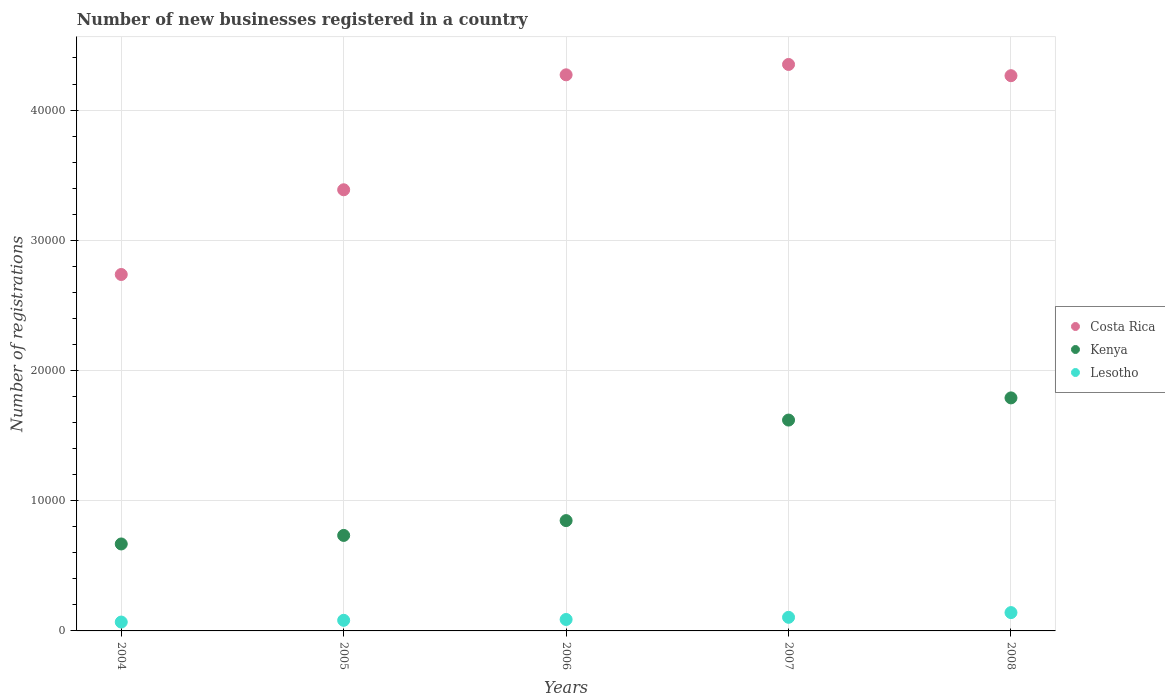Is the number of dotlines equal to the number of legend labels?
Make the answer very short. Yes. What is the number of new businesses registered in Kenya in 2005?
Provide a short and direct response. 7334. Across all years, what is the maximum number of new businesses registered in Costa Rica?
Ensure brevity in your answer.  4.35e+04. Across all years, what is the minimum number of new businesses registered in Lesotho?
Give a very brief answer. 681. In which year was the number of new businesses registered in Lesotho maximum?
Make the answer very short. 2008. In which year was the number of new businesses registered in Lesotho minimum?
Your answer should be compact. 2004. What is the total number of new businesses registered in Lesotho in the graph?
Keep it short and to the point. 4826. What is the difference between the number of new businesses registered in Lesotho in 2005 and that in 2006?
Your answer should be very brief. -65. What is the difference between the number of new businesses registered in Lesotho in 2005 and the number of new businesses registered in Costa Rica in 2007?
Offer a terse response. -4.27e+04. What is the average number of new businesses registered in Costa Rica per year?
Your response must be concise. 3.80e+04. In the year 2008, what is the difference between the number of new businesses registered in Lesotho and number of new businesses registered in Kenya?
Your answer should be very brief. -1.65e+04. What is the ratio of the number of new businesses registered in Costa Rica in 2004 to that in 2006?
Ensure brevity in your answer.  0.64. Is the number of new businesses registered in Costa Rica in 2005 less than that in 2008?
Provide a succinct answer. Yes. Is the difference between the number of new businesses registered in Lesotho in 2005 and 2007 greater than the difference between the number of new businesses registered in Kenya in 2005 and 2007?
Make the answer very short. Yes. What is the difference between the highest and the second highest number of new businesses registered in Kenya?
Your answer should be very brief. 1703. What is the difference between the highest and the lowest number of new businesses registered in Lesotho?
Provide a short and direct response. 726. Does the number of new businesses registered in Costa Rica monotonically increase over the years?
Your answer should be very brief. No. How many years are there in the graph?
Your answer should be very brief. 5. Does the graph contain any zero values?
Your answer should be compact. No. How many legend labels are there?
Provide a succinct answer. 3. What is the title of the graph?
Keep it short and to the point. Number of new businesses registered in a country. Does "Ecuador" appear as one of the legend labels in the graph?
Provide a short and direct response. No. What is the label or title of the X-axis?
Give a very brief answer. Years. What is the label or title of the Y-axis?
Give a very brief answer. Number of registrations. What is the Number of registrations in Costa Rica in 2004?
Offer a terse response. 2.74e+04. What is the Number of registrations in Kenya in 2004?
Offer a terse response. 6678. What is the Number of registrations of Lesotho in 2004?
Provide a succinct answer. 681. What is the Number of registrations of Costa Rica in 2005?
Give a very brief answer. 3.39e+04. What is the Number of registrations in Kenya in 2005?
Keep it short and to the point. 7334. What is the Number of registrations in Lesotho in 2005?
Your answer should be compact. 814. What is the Number of registrations of Costa Rica in 2006?
Provide a short and direct response. 4.27e+04. What is the Number of registrations of Kenya in 2006?
Offer a very short reply. 8472. What is the Number of registrations of Lesotho in 2006?
Provide a succinct answer. 879. What is the Number of registrations in Costa Rica in 2007?
Ensure brevity in your answer.  4.35e+04. What is the Number of registrations in Kenya in 2007?
Your answer should be very brief. 1.62e+04. What is the Number of registrations of Lesotho in 2007?
Make the answer very short. 1045. What is the Number of registrations of Costa Rica in 2008?
Keep it short and to the point. 4.26e+04. What is the Number of registrations of Kenya in 2008?
Your response must be concise. 1.79e+04. What is the Number of registrations of Lesotho in 2008?
Make the answer very short. 1407. Across all years, what is the maximum Number of registrations in Costa Rica?
Provide a short and direct response. 4.35e+04. Across all years, what is the maximum Number of registrations in Kenya?
Keep it short and to the point. 1.79e+04. Across all years, what is the maximum Number of registrations in Lesotho?
Make the answer very short. 1407. Across all years, what is the minimum Number of registrations of Costa Rica?
Make the answer very short. 2.74e+04. Across all years, what is the minimum Number of registrations of Kenya?
Your answer should be very brief. 6678. Across all years, what is the minimum Number of registrations of Lesotho?
Your response must be concise. 681. What is the total Number of registrations in Costa Rica in the graph?
Offer a terse response. 1.90e+05. What is the total Number of registrations in Kenya in the graph?
Offer a terse response. 5.66e+04. What is the total Number of registrations of Lesotho in the graph?
Ensure brevity in your answer.  4826. What is the difference between the Number of registrations of Costa Rica in 2004 and that in 2005?
Your response must be concise. -6506. What is the difference between the Number of registrations in Kenya in 2004 and that in 2005?
Keep it short and to the point. -656. What is the difference between the Number of registrations of Lesotho in 2004 and that in 2005?
Give a very brief answer. -133. What is the difference between the Number of registrations in Costa Rica in 2004 and that in 2006?
Provide a succinct answer. -1.53e+04. What is the difference between the Number of registrations of Kenya in 2004 and that in 2006?
Keep it short and to the point. -1794. What is the difference between the Number of registrations in Lesotho in 2004 and that in 2006?
Provide a short and direct response. -198. What is the difference between the Number of registrations of Costa Rica in 2004 and that in 2007?
Provide a short and direct response. -1.61e+04. What is the difference between the Number of registrations in Kenya in 2004 and that in 2007?
Your answer should be compact. -9515. What is the difference between the Number of registrations in Lesotho in 2004 and that in 2007?
Offer a terse response. -364. What is the difference between the Number of registrations of Costa Rica in 2004 and that in 2008?
Your response must be concise. -1.53e+04. What is the difference between the Number of registrations in Kenya in 2004 and that in 2008?
Give a very brief answer. -1.12e+04. What is the difference between the Number of registrations of Lesotho in 2004 and that in 2008?
Keep it short and to the point. -726. What is the difference between the Number of registrations in Costa Rica in 2005 and that in 2006?
Ensure brevity in your answer.  -8828. What is the difference between the Number of registrations of Kenya in 2005 and that in 2006?
Your answer should be very brief. -1138. What is the difference between the Number of registrations of Lesotho in 2005 and that in 2006?
Your answer should be compact. -65. What is the difference between the Number of registrations of Costa Rica in 2005 and that in 2007?
Give a very brief answer. -9624. What is the difference between the Number of registrations in Kenya in 2005 and that in 2007?
Offer a terse response. -8859. What is the difference between the Number of registrations in Lesotho in 2005 and that in 2007?
Provide a succinct answer. -231. What is the difference between the Number of registrations in Costa Rica in 2005 and that in 2008?
Offer a very short reply. -8761. What is the difference between the Number of registrations in Kenya in 2005 and that in 2008?
Make the answer very short. -1.06e+04. What is the difference between the Number of registrations of Lesotho in 2005 and that in 2008?
Offer a very short reply. -593. What is the difference between the Number of registrations of Costa Rica in 2006 and that in 2007?
Make the answer very short. -796. What is the difference between the Number of registrations in Kenya in 2006 and that in 2007?
Make the answer very short. -7721. What is the difference between the Number of registrations of Lesotho in 2006 and that in 2007?
Give a very brief answer. -166. What is the difference between the Number of registrations in Costa Rica in 2006 and that in 2008?
Give a very brief answer. 67. What is the difference between the Number of registrations of Kenya in 2006 and that in 2008?
Provide a succinct answer. -9424. What is the difference between the Number of registrations in Lesotho in 2006 and that in 2008?
Provide a short and direct response. -528. What is the difference between the Number of registrations in Costa Rica in 2007 and that in 2008?
Give a very brief answer. 863. What is the difference between the Number of registrations in Kenya in 2007 and that in 2008?
Make the answer very short. -1703. What is the difference between the Number of registrations in Lesotho in 2007 and that in 2008?
Your response must be concise. -362. What is the difference between the Number of registrations in Costa Rica in 2004 and the Number of registrations in Kenya in 2005?
Provide a succinct answer. 2.00e+04. What is the difference between the Number of registrations of Costa Rica in 2004 and the Number of registrations of Lesotho in 2005?
Make the answer very short. 2.66e+04. What is the difference between the Number of registrations of Kenya in 2004 and the Number of registrations of Lesotho in 2005?
Offer a terse response. 5864. What is the difference between the Number of registrations in Costa Rica in 2004 and the Number of registrations in Kenya in 2006?
Provide a short and direct response. 1.89e+04. What is the difference between the Number of registrations in Costa Rica in 2004 and the Number of registrations in Lesotho in 2006?
Your response must be concise. 2.65e+04. What is the difference between the Number of registrations of Kenya in 2004 and the Number of registrations of Lesotho in 2006?
Make the answer very short. 5799. What is the difference between the Number of registrations of Costa Rica in 2004 and the Number of registrations of Kenya in 2007?
Make the answer very short. 1.12e+04. What is the difference between the Number of registrations in Costa Rica in 2004 and the Number of registrations in Lesotho in 2007?
Your answer should be compact. 2.63e+04. What is the difference between the Number of registrations in Kenya in 2004 and the Number of registrations in Lesotho in 2007?
Ensure brevity in your answer.  5633. What is the difference between the Number of registrations in Costa Rica in 2004 and the Number of registrations in Kenya in 2008?
Give a very brief answer. 9477. What is the difference between the Number of registrations in Costa Rica in 2004 and the Number of registrations in Lesotho in 2008?
Keep it short and to the point. 2.60e+04. What is the difference between the Number of registrations of Kenya in 2004 and the Number of registrations of Lesotho in 2008?
Your response must be concise. 5271. What is the difference between the Number of registrations in Costa Rica in 2005 and the Number of registrations in Kenya in 2006?
Give a very brief answer. 2.54e+04. What is the difference between the Number of registrations of Costa Rica in 2005 and the Number of registrations of Lesotho in 2006?
Make the answer very short. 3.30e+04. What is the difference between the Number of registrations of Kenya in 2005 and the Number of registrations of Lesotho in 2006?
Your response must be concise. 6455. What is the difference between the Number of registrations of Costa Rica in 2005 and the Number of registrations of Kenya in 2007?
Your response must be concise. 1.77e+04. What is the difference between the Number of registrations in Costa Rica in 2005 and the Number of registrations in Lesotho in 2007?
Provide a succinct answer. 3.28e+04. What is the difference between the Number of registrations in Kenya in 2005 and the Number of registrations in Lesotho in 2007?
Offer a very short reply. 6289. What is the difference between the Number of registrations of Costa Rica in 2005 and the Number of registrations of Kenya in 2008?
Your response must be concise. 1.60e+04. What is the difference between the Number of registrations in Costa Rica in 2005 and the Number of registrations in Lesotho in 2008?
Make the answer very short. 3.25e+04. What is the difference between the Number of registrations of Kenya in 2005 and the Number of registrations of Lesotho in 2008?
Provide a succinct answer. 5927. What is the difference between the Number of registrations in Costa Rica in 2006 and the Number of registrations in Kenya in 2007?
Your answer should be very brief. 2.65e+04. What is the difference between the Number of registrations in Costa Rica in 2006 and the Number of registrations in Lesotho in 2007?
Offer a terse response. 4.17e+04. What is the difference between the Number of registrations in Kenya in 2006 and the Number of registrations in Lesotho in 2007?
Give a very brief answer. 7427. What is the difference between the Number of registrations of Costa Rica in 2006 and the Number of registrations of Kenya in 2008?
Make the answer very short. 2.48e+04. What is the difference between the Number of registrations in Costa Rica in 2006 and the Number of registrations in Lesotho in 2008?
Offer a terse response. 4.13e+04. What is the difference between the Number of registrations in Kenya in 2006 and the Number of registrations in Lesotho in 2008?
Provide a succinct answer. 7065. What is the difference between the Number of registrations of Costa Rica in 2007 and the Number of registrations of Kenya in 2008?
Your response must be concise. 2.56e+04. What is the difference between the Number of registrations of Costa Rica in 2007 and the Number of registrations of Lesotho in 2008?
Give a very brief answer. 4.21e+04. What is the difference between the Number of registrations of Kenya in 2007 and the Number of registrations of Lesotho in 2008?
Your answer should be very brief. 1.48e+04. What is the average Number of registrations in Costa Rica per year?
Ensure brevity in your answer.  3.80e+04. What is the average Number of registrations in Kenya per year?
Provide a short and direct response. 1.13e+04. What is the average Number of registrations in Lesotho per year?
Your answer should be very brief. 965.2. In the year 2004, what is the difference between the Number of registrations of Costa Rica and Number of registrations of Kenya?
Provide a succinct answer. 2.07e+04. In the year 2004, what is the difference between the Number of registrations of Costa Rica and Number of registrations of Lesotho?
Offer a very short reply. 2.67e+04. In the year 2004, what is the difference between the Number of registrations in Kenya and Number of registrations in Lesotho?
Keep it short and to the point. 5997. In the year 2005, what is the difference between the Number of registrations of Costa Rica and Number of registrations of Kenya?
Offer a very short reply. 2.65e+04. In the year 2005, what is the difference between the Number of registrations in Costa Rica and Number of registrations in Lesotho?
Your response must be concise. 3.31e+04. In the year 2005, what is the difference between the Number of registrations in Kenya and Number of registrations in Lesotho?
Your answer should be compact. 6520. In the year 2006, what is the difference between the Number of registrations of Costa Rica and Number of registrations of Kenya?
Your response must be concise. 3.42e+04. In the year 2006, what is the difference between the Number of registrations of Costa Rica and Number of registrations of Lesotho?
Your answer should be very brief. 4.18e+04. In the year 2006, what is the difference between the Number of registrations in Kenya and Number of registrations in Lesotho?
Provide a short and direct response. 7593. In the year 2007, what is the difference between the Number of registrations of Costa Rica and Number of registrations of Kenya?
Make the answer very short. 2.73e+04. In the year 2007, what is the difference between the Number of registrations of Costa Rica and Number of registrations of Lesotho?
Keep it short and to the point. 4.25e+04. In the year 2007, what is the difference between the Number of registrations in Kenya and Number of registrations in Lesotho?
Give a very brief answer. 1.51e+04. In the year 2008, what is the difference between the Number of registrations of Costa Rica and Number of registrations of Kenya?
Give a very brief answer. 2.47e+04. In the year 2008, what is the difference between the Number of registrations in Costa Rica and Number of registrations in Lesotho?
Your answer should be compact. 4.12e+04. In the year 2008, what is the difference between the Number of registrations of Kenya and Number of registrations of Lesotho?
Your answer should be very brief. 1.65e+04. What is the ratio of the Number of registrations of Costa Rica in 2004 to that in 2005?
Your answer should be very brief. 0.81. What is the ratio of the Number of registrations in Kenya in 2004 to that in 2005?
Give a very brief answer. 0.91. What is the ratio of the Number of registrations in Lesotho in 2004 to that in 2005?
Keep it short and to the point. 0.84. What is the ratio of the Number of registrations of Costa Rica in 2004 to that in 2006?
Provide a succinct answer. 0.64. What is the ratio of the Number of registrations of Kenya in 2004 to that in 2006?
Your response must be concise. 0.79. What is the ratio of the Number of registrations in Lesotho in 2004 to that in 2006?
Give a very brief answer. 0.77. What is the ratio of the Number of registrations of Costa Rica in 2004 to that in 2007?
Provide a succinct answer. 0.63. What is the ratio of the Number of registrations in Kenya in 2004 to that in 2007?
Your answer should be very brief. 0.41. What is the ratio of the Number of registrations of Lesotho in 2004 to that in 2007?
Provide a succinct answer. 0.65. What is the ratio of the Number of registrations of Costa Rica in 2004 to that in 2008?
Provide a succinct answer. 0.64. What is the ratio of the Number of registrations of Kenya in 2004 to that in 2008?
Give a very brief answer. 0.37. What is the ratio of the Number of registrations in Lesotho in 2004 to that in 2008?
Your answer should be compact. 0.48. What is the ratio of the Number of registrations of Costa Rica in 2005 to that in 2006?
Make the answer very short. 0.79. What is the ratio of the Number of registrations in Kenya in 2005 to that in 2006?
Your answer should be very brief. 0.87. What is the ratio of the Number of registrations of Lesotho in 2005 to that in 2006?
Provide a succinct answer. 0.93. What is the ratio of the Number of registrations in Costa Rica in 2005 to that in 2007?
Your answer should be very brief. 0.78. What is the ratio of the Number of registrations of Kenya in 2005 to that in 2007?
Your answer should be very brief. 0.45. What is the ratio of the Number of registrations in Lesotho in 2005 to that in 2007?
Provide a succinct answer. 0.78. What is the ratio of the Number of registrations in Costa Rica in 2005 to that in 2008?
Give a very brief answer. 0.79. What is the ratio of the Number of registrations in Kenya in 2005 to that in 2008?
Your answer should be very brief. 0.41. What is the ratio of the Number of registrations of Lesotho in 2005 to that in 2008?
Offer a terse response. 0.58. What is the ratio of the Number of registrations of Costa Rica in 2006 to that in 2007?
Keep it short and to the point. 0.98. What is the ratio of the Number of registrations of Kenya in 2006 to that in 2007?
Provide a short and direct response. 0.52. What is the ratio of the Number of registrations of Lesotho in 2006 to that in 2007?
Your response must be concise. 0.84. What is the ratio of the Number of registrations of Kenya in 2006 to that in 2008?
Provide a short and direct response. 0.47. What is the ratio of the Number of registrations in Lesotho in 2006 to that in 2008?
Provide a short and direct response. 0.62. What is the ratio of the Number of registrations in Costa Rica in 2007 to that in 2008?
Keep it short and to the point. 1.02. What is the ratio of the Number of registrations of Kenya in 2007 to that in 2008?
Ensure brevity in your answer.  0.9. What is the ratio of the Number of registrations in Lesotho in 2007 to that in 2008?
Provide a short and direct response. 0.74. What is the difference between the highest and the second highest Number of registrations of Costa Rica?
Your answer should be compact. 796. What is the difference between the highest and the second highest Number of registrations of Kenya?
Offer a terse response. 1703. What is the difference between the highest and the second highest Number of registrations in Lesotho?
Keep it short and to the point. 362. What is the difference between the highest and the lowest Number of registrations in Costa Rica?
Offer a very short reply. 1.61e+04. What is the difference between the highest and the lowest Number of registrations in Kenya?
Make the answer very short. 1.12e+04. What is the difference between the highest and the lowest Number of registrations in Lesotho?
Give a very brief answer. 726. 